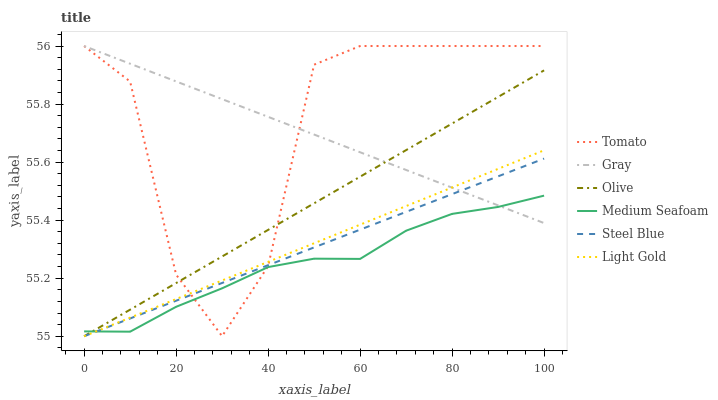Does Medium Seafoam have the minimum area under the curve?
Answer yes or no. Yes. Does Tomato have the maximum area under the curve?
Answer yes or no. Yes. Does Gray have the minimum area under the curve?
Answer yes or no. No. Does Gray have the maximum area under the curve?
Answer yes or no. No. Is Olive the smoothest?
Answer yes or no. Yes. Is Tomato the roughest?
Answer yes or no. Yes. Is Gray the smoothest?
Answer yes or no. No. Is Gray the roughest?
Answer yes or no. No. Does Steel Blue have the lowest value?
Answer yes or no. Yes. Does Gray have the lowest value?
Answer yes or no. No. Does Gray have the highest value?
Answer yes or no. Yes. Does Steel Blue have the highest value?
Answer yes or no. No. Does Medium Seafoam intersect Tomato?
Answer yes or no. Yes. Is Medium Seafoam less than Tomato?
Answer yes or no. No. Is Medium Seafoam greater than Tomato?
Answer yes or no. No. 